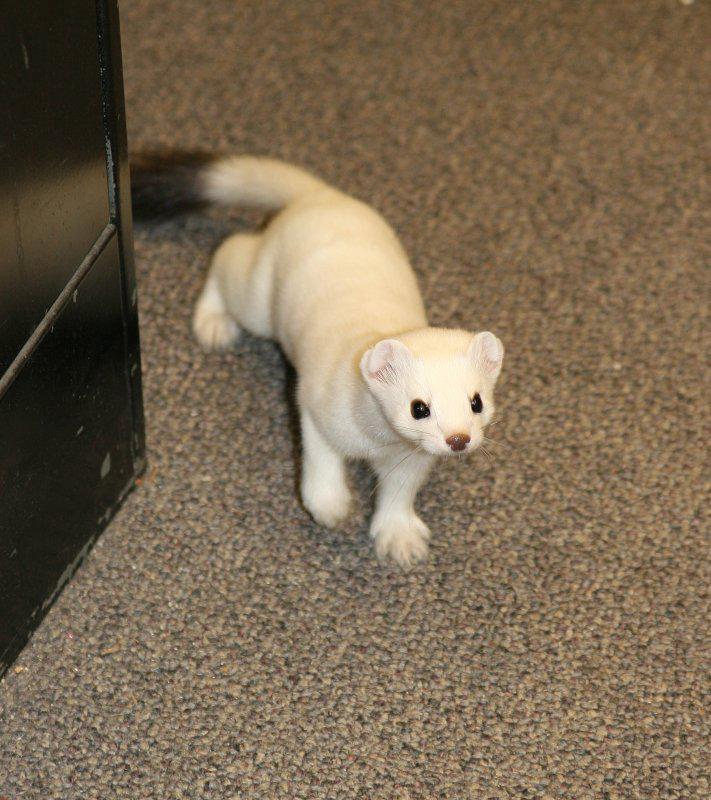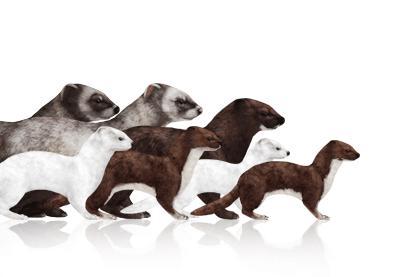The first image is the image on the left, the second image is the image on the right. Assess this claim about the two images: "At least 1 of the animals is standing outdoors.". Correct or not? Answer yes or no. No. 